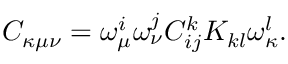Convert formula to latex. <formula><loc_0><loc_0><loc_500><loc_500>C _ { \kappa \mu \nu } = \omega _ { \mu } ^ { i } \omega _ { \nu } ^ { j } C _ { i j } ^ { k } K _ { k l } \omega _ { \kappa } ^ { l } .</formula> 